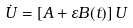Convert formula to latex. <formula><loc_0><loc_0><loc_500><loc_500>\dot { U } = \left [ { A } + \varepsilon { B } ( t ) \right ] { U }</formula> 